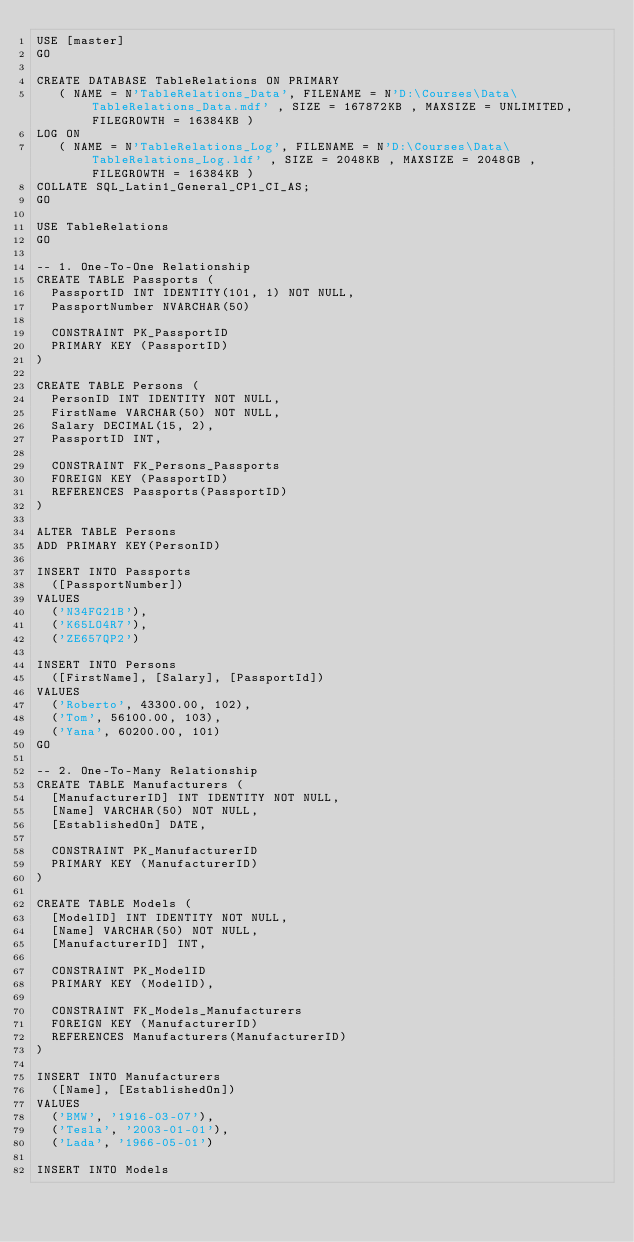Convert code to text. <code><loc_0><loc_0><loc_500><loc_500><_SQL_>USE [master]
GO

CREATE DATABASE TableRelations ON PRIMARY
   ( NAME = N'TableRelations_Data', FILENAME = N'D:\Courses\Data\TableRelations_Data.mdf' , SIZE = 167872KB , MAXSIZE = UNLIMITED, FILEGROWTH = 16384KB )
LOG ON
   ( NAME = N'TableRelations_Log', FILENAME = N'D:\Courses\Data\TableRelations_Log.ldf' , SIZE = 2048KB , MAXSIZE = 2048GB , FILEGROWTH = 16384KB )
COLLATE SQL_Latin1_General_CP1_CI_AS;
GO

USE TableRelations
GO

-- 1. One-To-One Relationship 
CREATE TABLE Passports (
	PassportID INT IDENTITY(101, 1) NOT NULL,
	PassportNumber NVARCHAR(50)

	CONSTRAINT PK_PassportID
	PRIMARY KEY (PassportID)
)

CREATE TABLE Persons (
	PersonID INT IDENTITY NOT NULL,
	FirstName VARCHAR(50) NOT NULL,
	Salary DECIMAL(15, 2),
	PassportID INT,

	CONSTRAINT FK_Persons_Passports
	FOREIGN KEY (PassportID) 
	REFERENCES Passports(PassportID)
)

ALTER TABLE Persons 
ADD PRIMARY KEY(PersonID)

INSERT INTO Passports
	([PassportNumber])
VALUES
	('N34FG21B'), 
	('K65LO4R7'), 
	('ZE657QP2')

INSERT INTO Persons 
	([FirstName], [Salary], [PassportId])
VALUES
	('Roberto', 43300.00, 102),
	('Tom', 56100.00, 103),
	('Yana', 60200.00, 101)
GO

-- 2. One-To-Many Relationship 
CREATE TABLE Manufacturers (
	[ManufacturerID] INT IDENTITY NOT NULL,
	[Name] VARCHAR(50) NOT NULL,
	[EstablishedOn] DATE,

	CONSTRAINT PK_ManufacturerID
	PRIMARY KEY (ManufacturerID)
)

CREATE TABLE Models (
	[ModelID] INT IDENTITY NOT NULL,
	[Name] VARCHAR(50) NOT NULL,
	[ManufacturerID] INT,

	CONSTRAINT PK_ModelID
	PRIMARY KEY (ModelID),

	CONSTRAINT FK_Models_Manufacturers
	FOREIGN KEY (ManufacturerID)
	REFERENCES Manufacturers(ManufacturerID)
)

INSERT INTO Manufacturers 
	([Name], [EstablishedOn])
VALUES
	('BMW', '1916-03-07'),
	('Tesla', '2003-01-01'),
	('Lada', '1966-05-01')

INSERT INTO Models </code> 